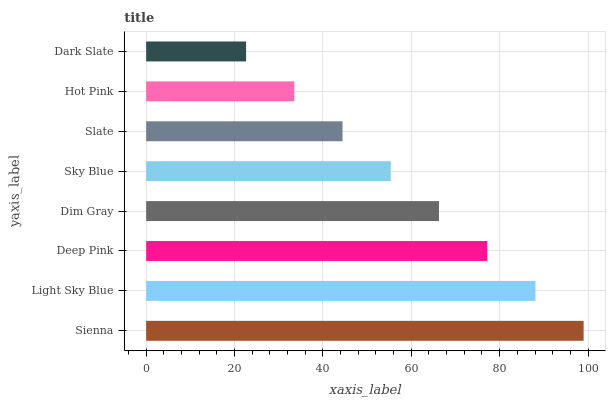Is Dark Slate the minimum?
Answer yes or no. Yes. Is Sienna the maximum?
Answer yes or no. Yes. Is Light Sky Blue the minimum?
Answer yes or no. No. Is Light Sky Blue the maximum?
Answer yes or no. No. Is Sienna greater than Light Sky Blue?
Answer yes or no. Yes. Is Light Sky Blue less than Sienna?
Answer yes or no. Yes. Is Light Sky Blue greater than Sienna?
Answer yes or no. No. Is Sienna less than Light Sky Blue?
Answer yes or no. No. Is Dim Gray the high median?
Answer yes or no. Yes. Is Sky Blue the low median?
Answer yes or no. Yes. Is Slate the high median?
Answer yes or no. No. Is Dark Slate the low median?
Answer yes or no. No. 